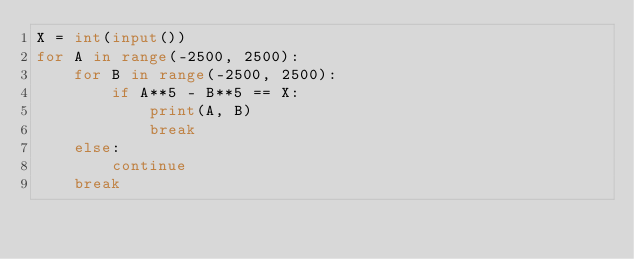Convert code to text. <code><loc_0><loc_0><loc_500><loc_500><_Python_>X = int(input())
for A in range(-2500, 2500):
    for B in range(-2500, 2500):
        if A**5 - B**5 == X:
            print(A, B)
            break
    else:
        continue
    break</code> 